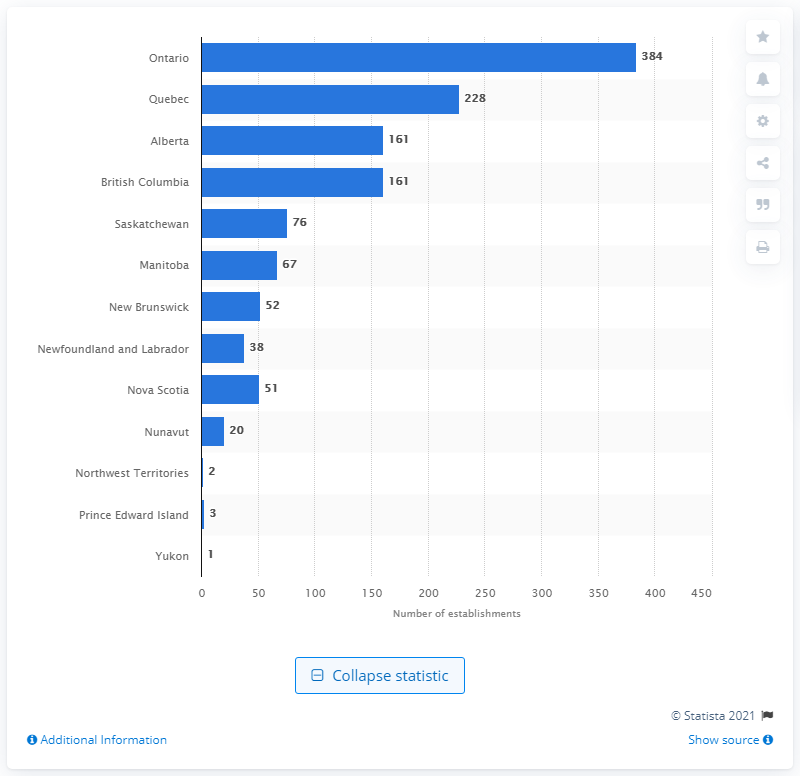Indicate a few pertinent items in this graphic. Ontario has the largest number of hospitals among all the Canadian provinces. 